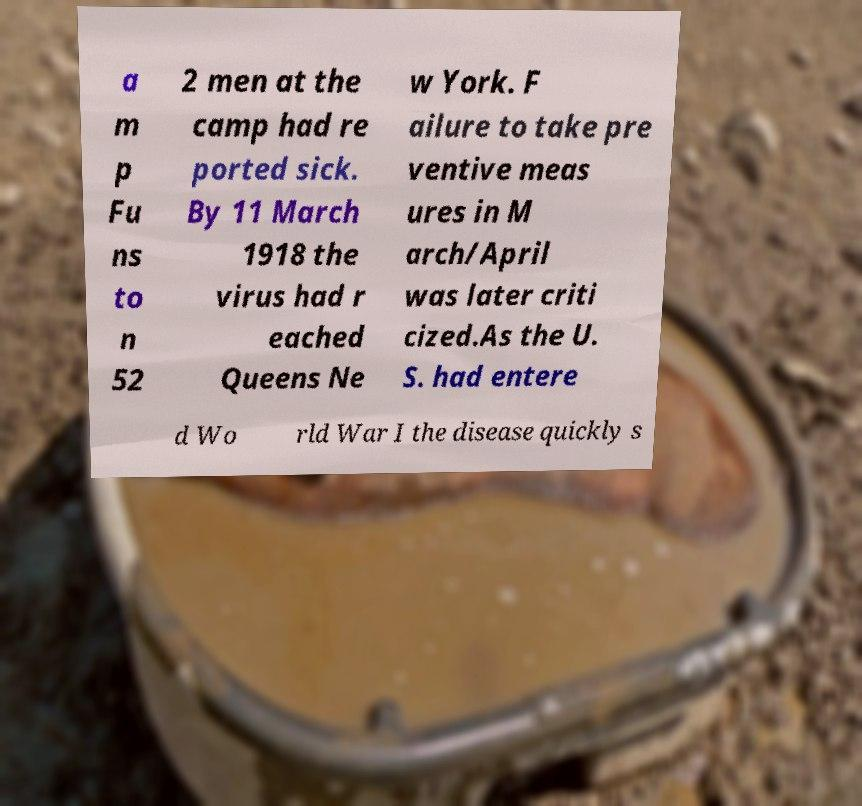What messages or text are displayed in this image? I need them in a readable, typed format. a m p Fu ns to n 52 2 men at the camp had re ported sick. By 11 March 1918 the virus had r eached Queens Ne w York. F ailure to take pre ventive meas ures in M arch/April was later criti cized.As the U. S. had entere d Wo rld War I the disease quickly s 